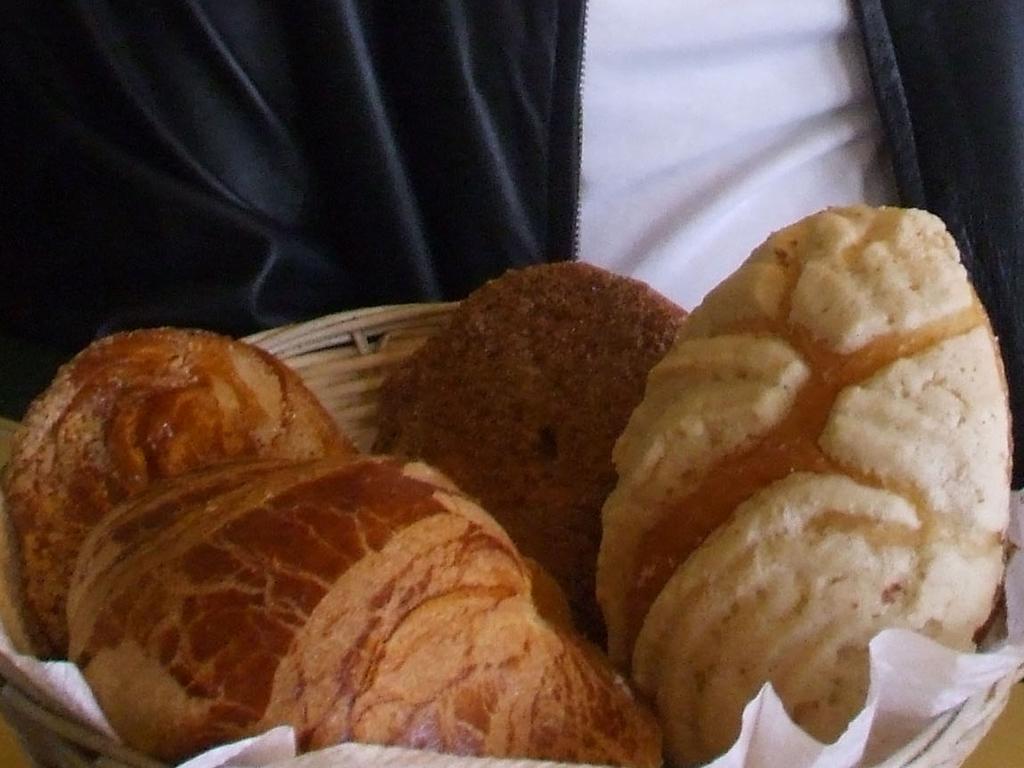Please provide a concise description of this image. In this image there is a food item placed in a basket, in front of that there is a person. 